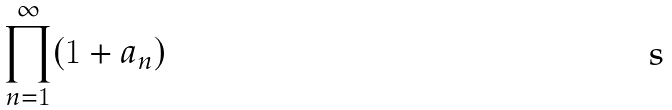Convert formula to latex. <formula><loc_0><loc_0><loc_500><loc_500>\prod _ { n = 1 } ^ { \infty } ( 1 + a _ { n } )</formula> 